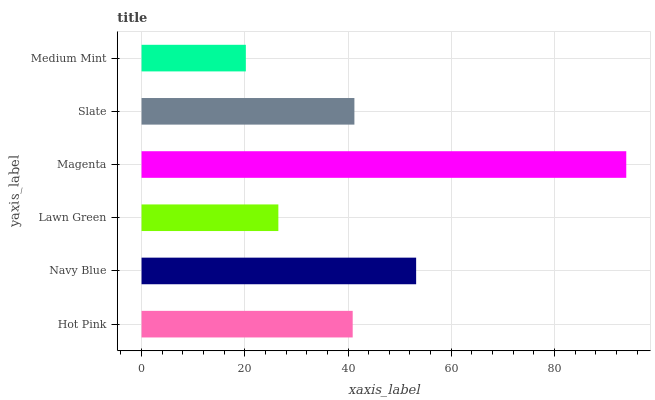Is Medium Mint the minimum?
Answer yes or no. Yes. Is Magenta the maximum?
Answer yes or no. Yes. Is Navy Blue the minimum?
Answer yes or no. No. Is Navy Blue the maximum?
Answer yes or no. No. Is Navy Blue greater than Hot Pink?
Answer yes or no. Yes. Is Hot Pink less than Navy Blue?
Answer yes or no. Yes. Is Hot Pink greater than Navy Blue?
Answer yes or no. No. Is Navy Blue less than Hot Pink?
Answer yes or no. No. Is Slate the high median?
Answer yes or no. Yes. Is Hot Pink the low median?
Answer yes or no. Yes. Is Medium Mint the high median?
Answer yes or no. No. Is Lawn Green the low median?
Answer yes or no. No. 